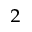Convert formula to latex. <formula><loc_0><loc_0><loc_500><loc_500>_ { 2 }</formula> 